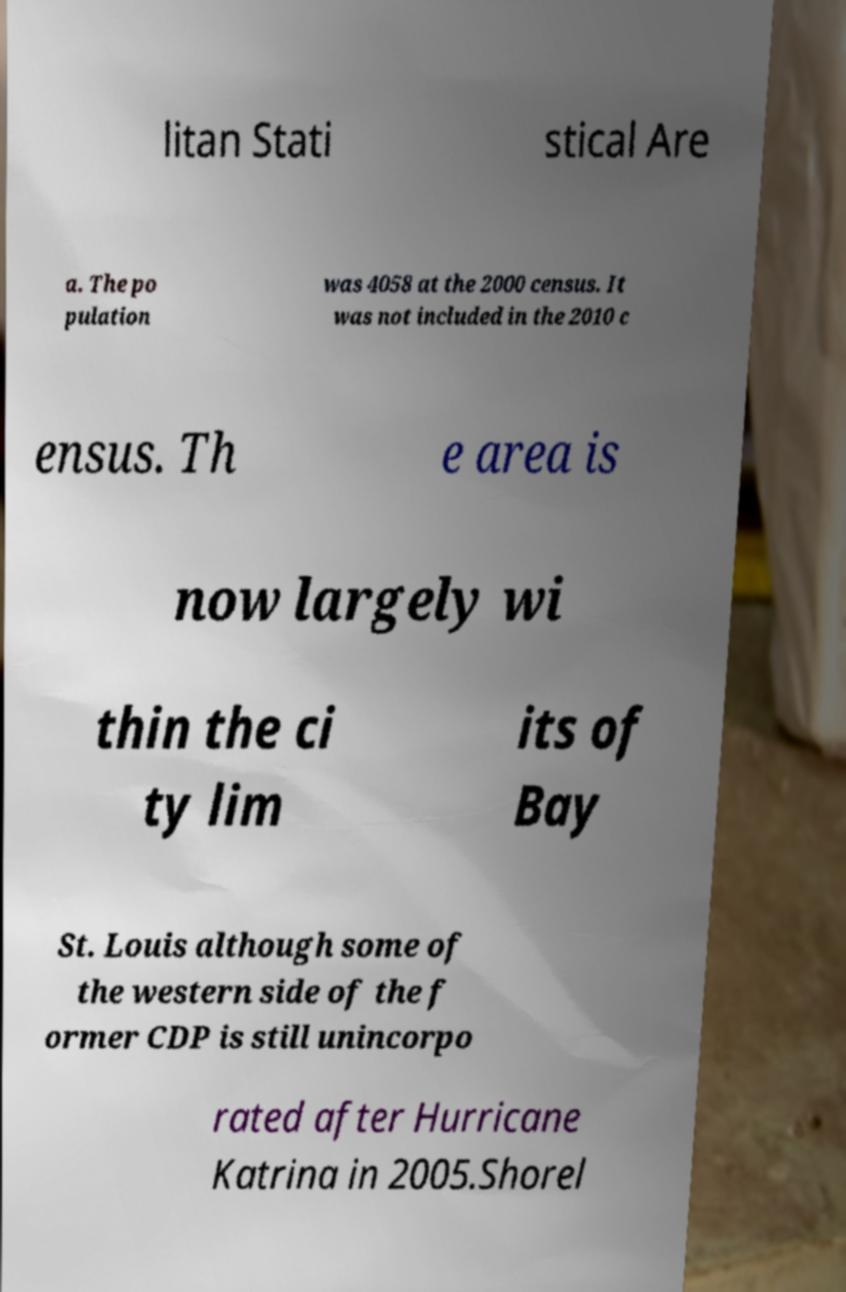For documentation purposes, I need the text within this image transcribed. Could you provide that? litan Stati stical Are a. The po pulation was 4058 at the 2000 census. It was not included in the 2010 c ensus. Th e area is now largely wi thin the ci ty lim its of Bay St. Louis although some of the western side of the f ormer CDP is still unincorpo rated after Hurricane Katrina in 2005.Shorel 